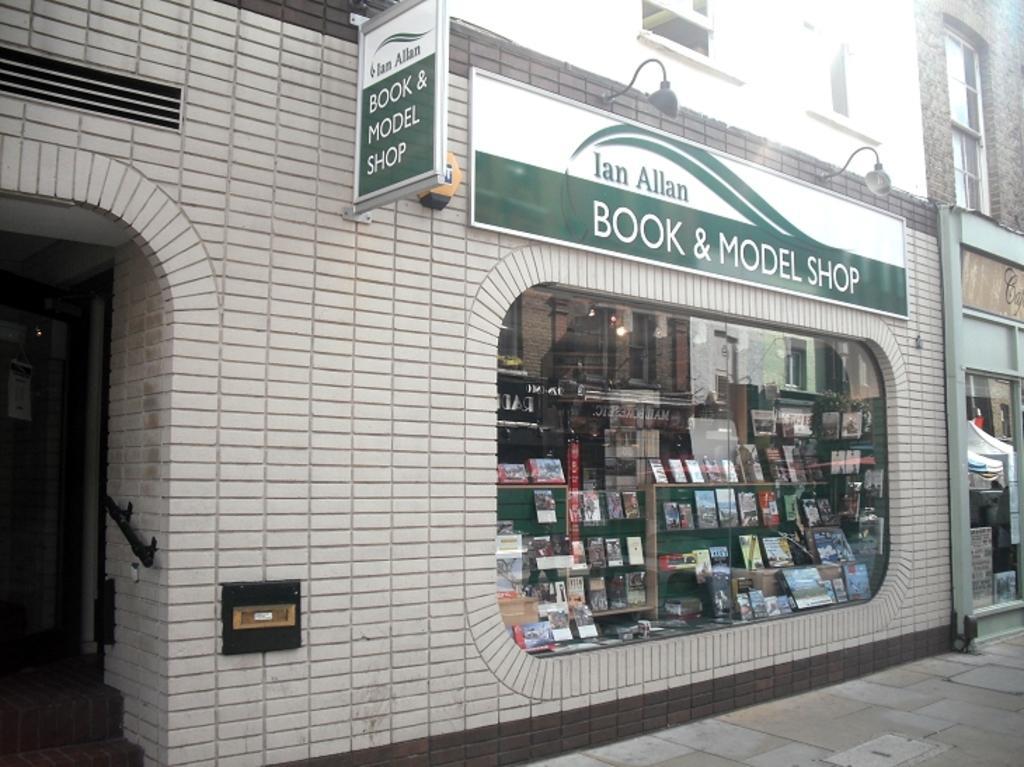Could you give a brief overview of what you see in this image? This picture is clicked outside. On the right we can see the pavement. On the left there is a building and we can see the text on the boards which are attached to the wall of the building and we can see the wall mounted lamps and we can see the windows of the building and through the window we can see the cabinets containing many objects and we can see the light and some other objects. 